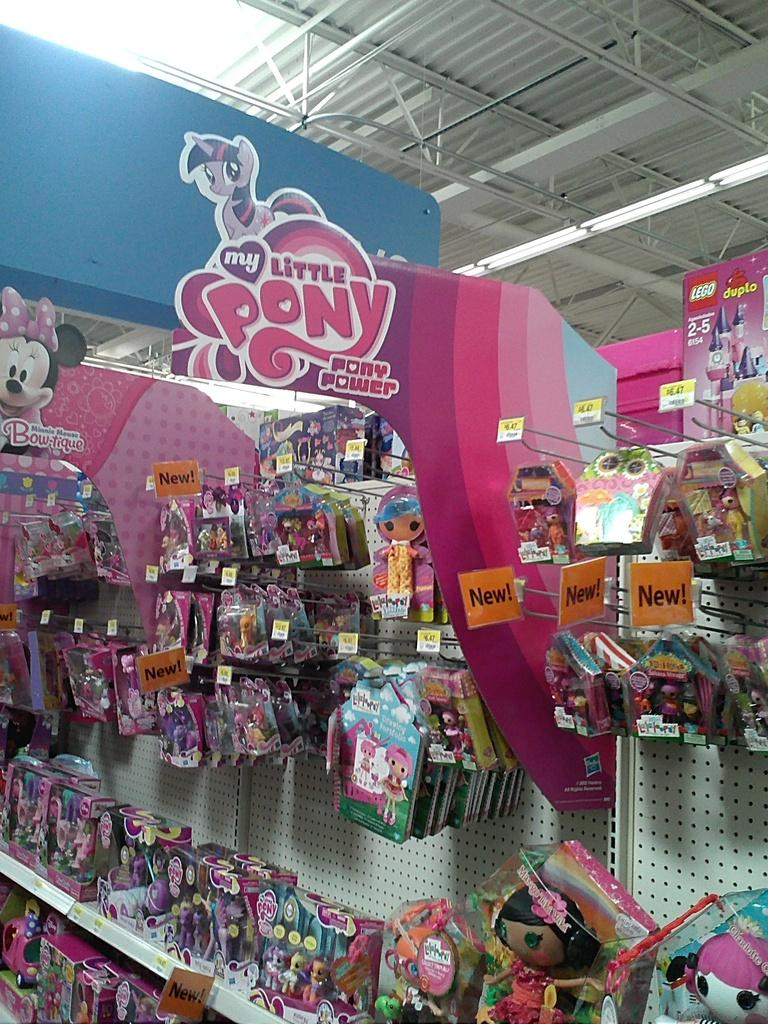Provide a one-sentence caption for the provided image. A store section for the cartoon My Little Pony. 